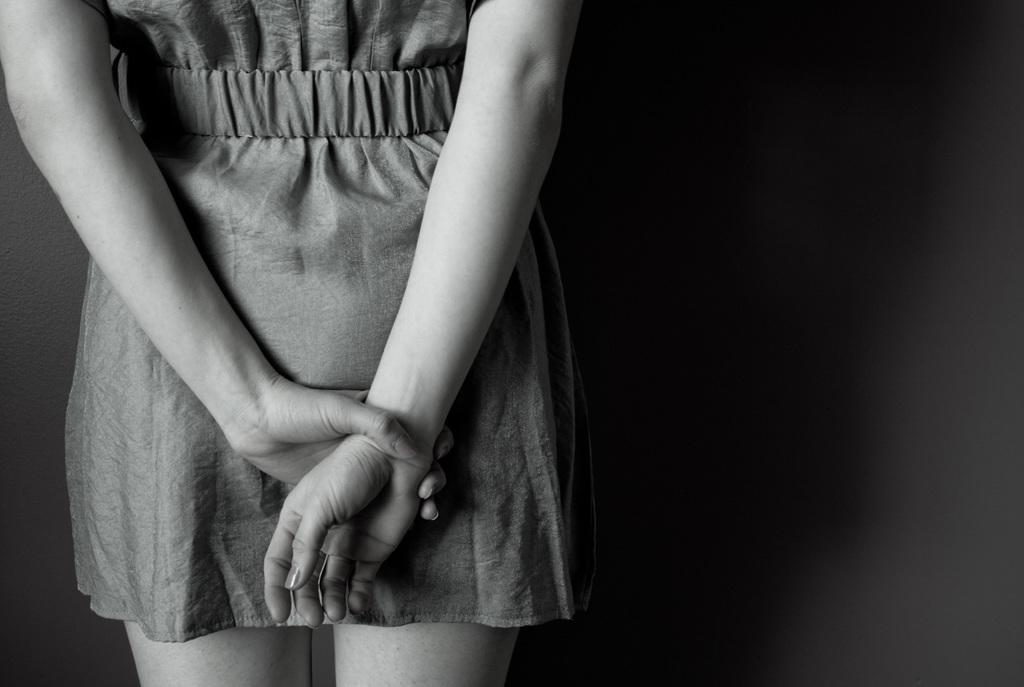Who is the main subject in the image? There is a girl in the image. Where is the girl positioned in the image? The girl is standing on the left side of the image. What type of crown is the girl wearing in the image? There is no crown present in the image; the girl is not wearing any headgear. 